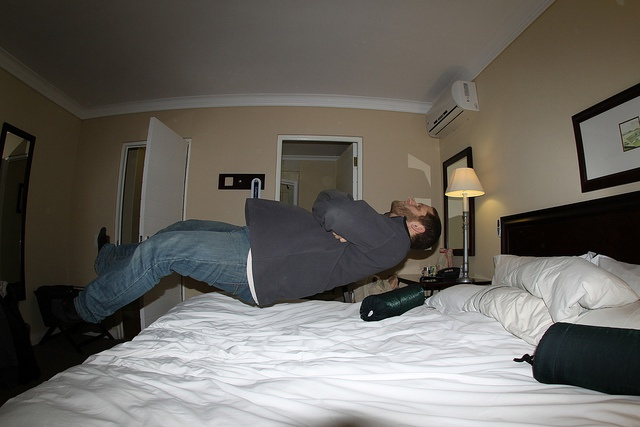Describe the objects in this image and their specific colors. I can see bed in black, lightgray, darkgray, and gray tones, people in black, gray, and blue tones, cup in black, gray, and maroon tones, and bottle in black, gray, and maroon tones in this image. 